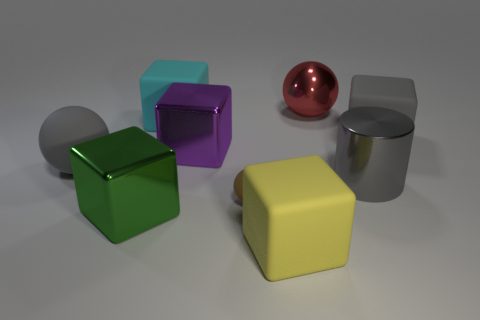The large metallic object behind the large purple cube has what shape?
Offer a terse response. Sphere. What number of green objects are tiny balls or matte objects?
Your answer should be very brief. 0. Are the gray sphere and the large green cube made of the same material?
Your answer should be compact. No. How many green things are right of the big metallic sphere?
Your response must be concise. 0. There is a big block that is both in front of the gray cylinder and on the left side of the big purple metal thing; what material is it?
Provide a succinct answer. Metal. What number of balls are either big gray rubber objects or green objects?
Your answer should be very brief. 1. There is a large purple object that is the same shape as the green thing; what is its material?
Offer a terse response. Metal. There is a brown sphere that is made of the same material as the big gray ball; what size is it?
Provide a succinct answer. Small. Is the shape of the large gray matte object that is on the right side of the purple metal cube the same as the rubber object that is in front of the tiny brown matte object?
Give a very brief answer. Yes. There is another large cube that is the same material as the big purple block; what is its color?
Offer a very short reply. Green. 